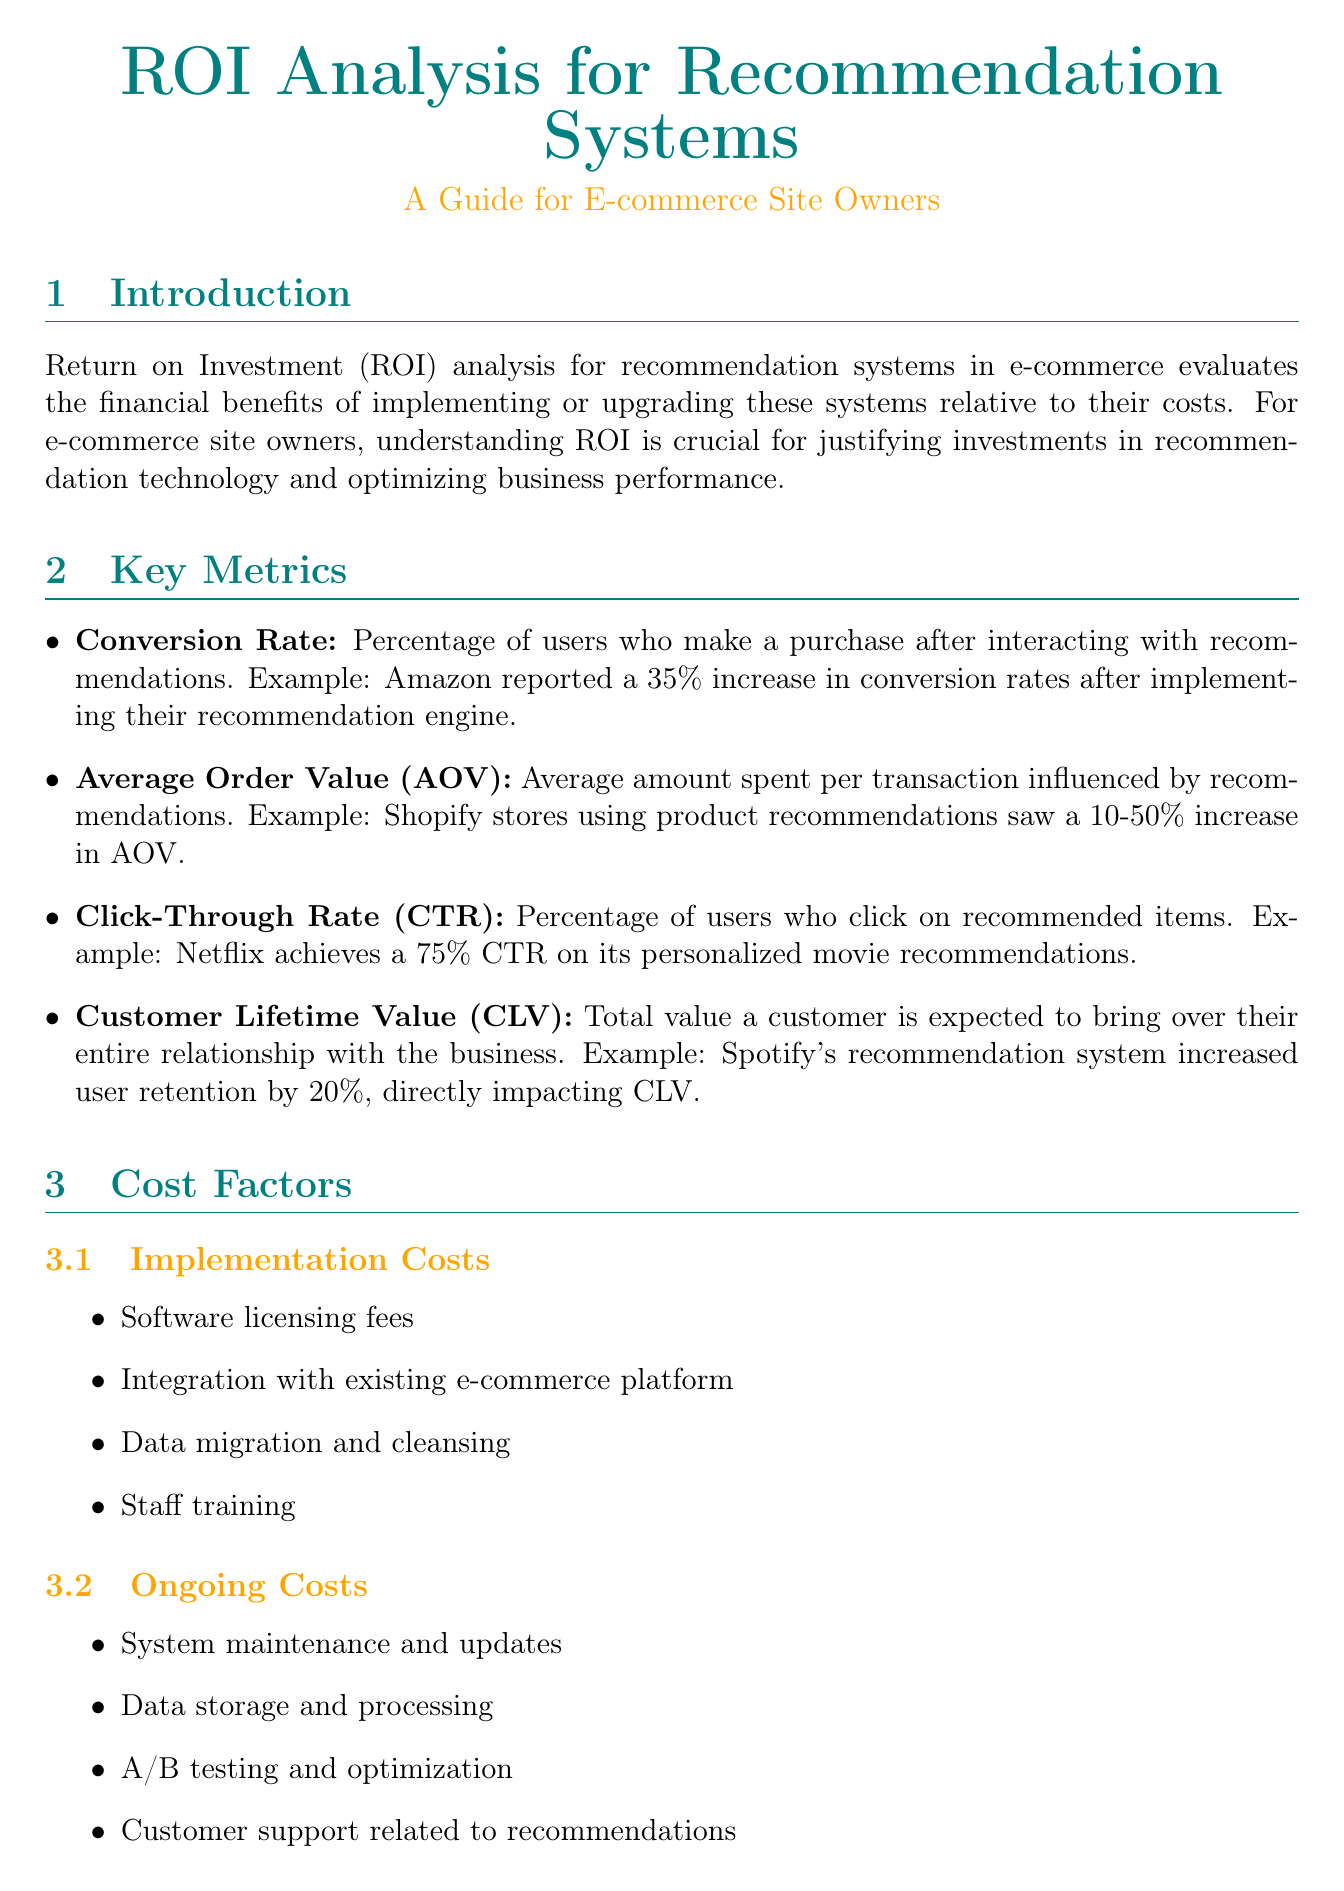What is ROI? ROI stands for Return on Investment, which evaluates the financial benefits of implementing or upgrading recommendation systems relative to their costs.
Answer: Return on Investment What was Etsy's increase in overall sales? Etsy's implementation of a recommendation system resulted in a 20% boost in overall sales.
Answer: 20% What key metric measures the percentage of users who purchase after recommendations? This key metric is called Conversion Rate.
Answer: Conversion Rate What is the formula for ROI calculation? The formula for ROI calculation outlined in the document is (Gain from Investment - Cost of Investment) / Cost of Investment.
Answer: (Gain from Investment - Cost of Investment) / Cost of Investment What challenge is associated with data privacy? Data privacy and security present a challenge for recommendation systems.
Answer: Data privacy and security What percentage increase in average order value did Shopify stores experience using recommendations? Shopify stores saw a 10-50% increase in Average Order Value.
Answer: 10-50% Which company implemented a visual search and recommendation engine? Wayfair implemented a visual search and recommendation engine.
Answer: Wayfair What is one best practice for recommendation systems? One best practice is to regularly update and refine the recommendation algorithm.
Answer: Regularly update and refine the recommendation algorithm 